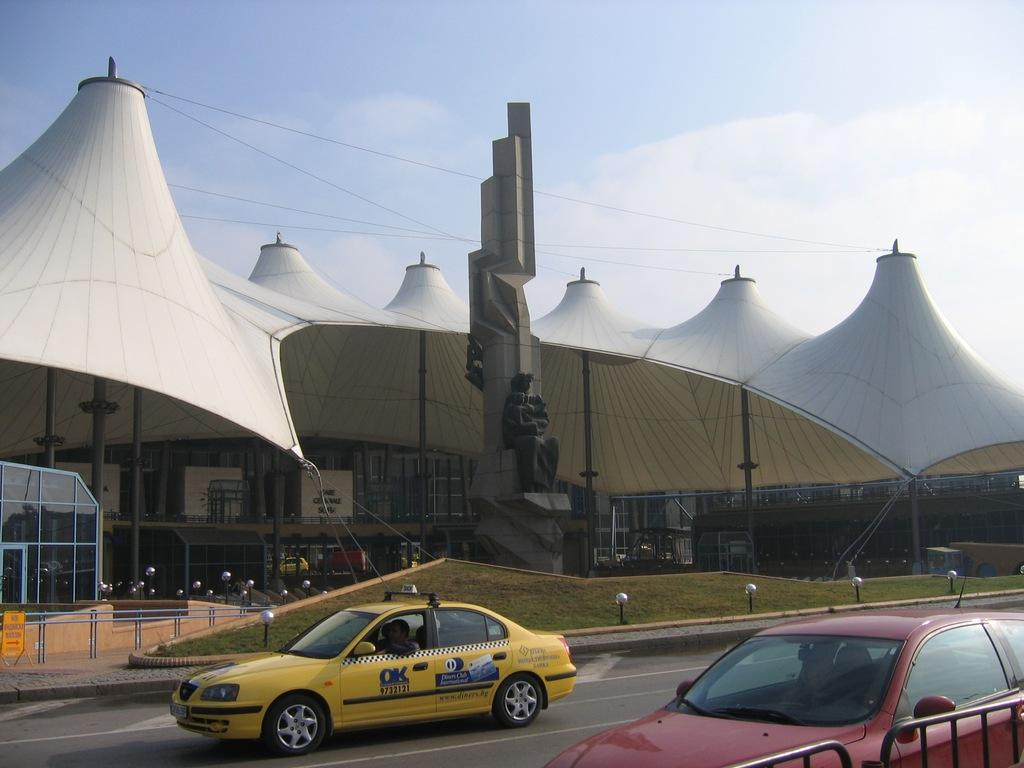<image>
Give a short and clear explanation of the subsequent image. An OK cab in front of a landmark. 